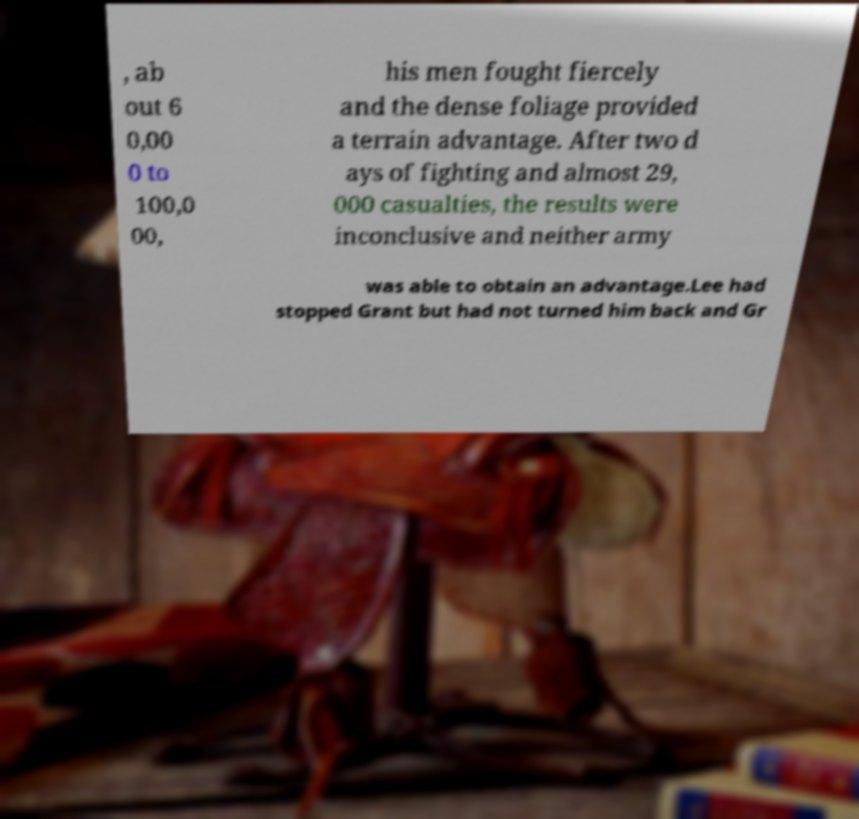Can you accurately transcribe the text from the provided image for me? , ab out 6 0,00 0 to 100,0 00, his men fought fiercely and the dense foliage provided a terrain advantage. After two d ays of fighting and almost 29, 000 casualties, the results were inconclusive and neither army was able to obtain an advantage.Lee had stopped Grant but had not turned him back and Gr 